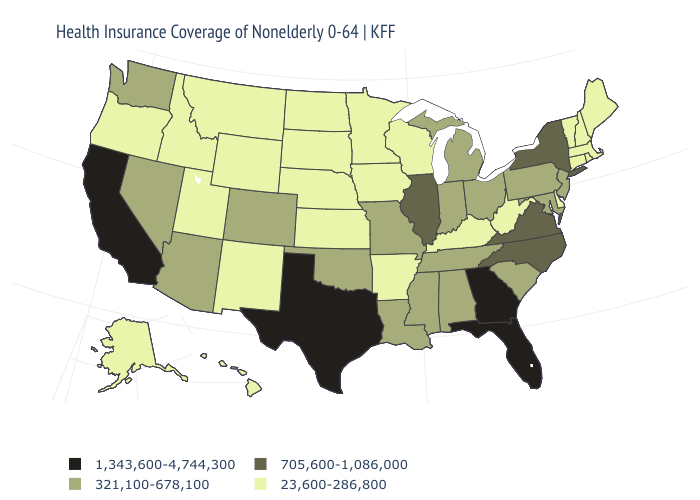Does Michigan have the same value as Iowa?
Answer briefly. No. Does the first symbol in the legend represent the smallest category?
Give a very brief answer. No. What is the highest value in the MidWest ?
Short answer required. 705,600-1,086,000. Which states have the lowest value in the USA?
Short answer required. Alaska, Arkansas, Connecticut, Delaware, Hawaii, Idaho, Iowa, Kansas, Kentucky, Maine, Massachusetts, Minnesota, Montana, Nebraska, New Hampshire, New Mexico, North Dakota, Oregon, Rhode Island, South Dakota, Utah, Vermont, West Virginia, Wisconsin, Wyoming. Which states have the lowest value in the Northeast?
Answer briefly. Connecticut, Maine, Massachusetts, New Hampshire, Rhode Island, Vermont. Name the states that have a value in the range 1,343,600-4,744,300?
Short answer required. California, Florida, Georgia, Texas. What is the value of Delaware?
Be succinct. 23,600-286,800. Does Alabama have a lower value than Massachusetts?
Give a very brief answer. No. What is the value of Missouri?
Write a very short answer. 321,100-678,100. Which states have the highest value in the USA?
Quick response, please. California, Florida, Georgia, Texas. What is the highest value in the USA?
Be succinct. 1,343,600-4,744,300. What is the value of Wisconsin?
Concise answer only. 23,600-286,800. What is the lowest value in states that border Texas?
Answer briefly. 23,600-286,800. What is the lowest value in the Northeast?
Answer briefly. 23,600-286,800. Does the first symbol in the legend represent the smallest category?
Short answer required. No. 